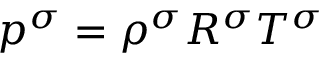Convert formula to latex. <formula><loc_0><loc_0><loc_500><loc_500>p ^ { \sigma } = \rho ^ { \sigma } R ^ { \sigma } T ^ { \sigma }</formula> 